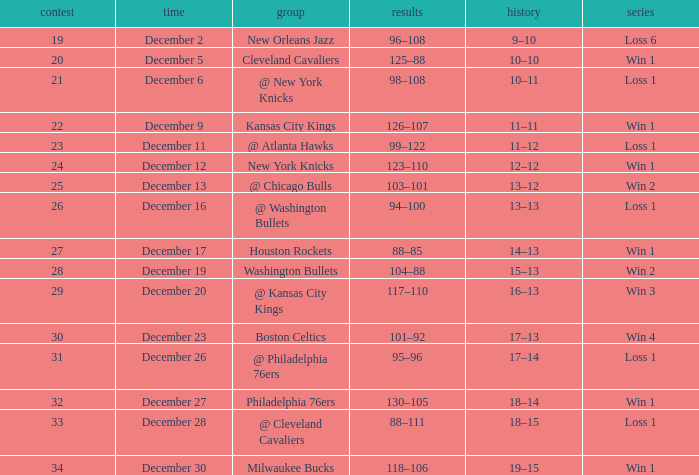With a 13-12 record, what is the current score of the game? 103–101. 